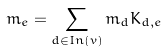<formula> <loc_0><loc_0><loc_500><loc_500>m _ { e } = \sum _ { d \in I n ( v ) } m _ { d } K _ { d , e }</formula> 